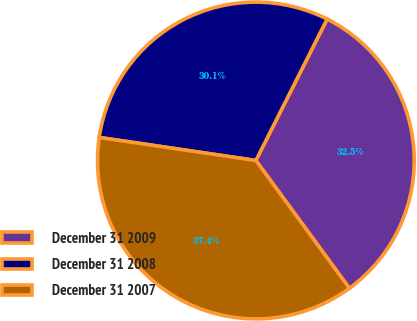<chart> <loc_0><loc_0><loc_500><loc_500><pie_chart><fcel>December 31 2009<fcel>December 31 2008<fcel>December 31 2007<nl><fcel>32.52%<fcel>30.1%<fcel>37.38%<nl></chart> 